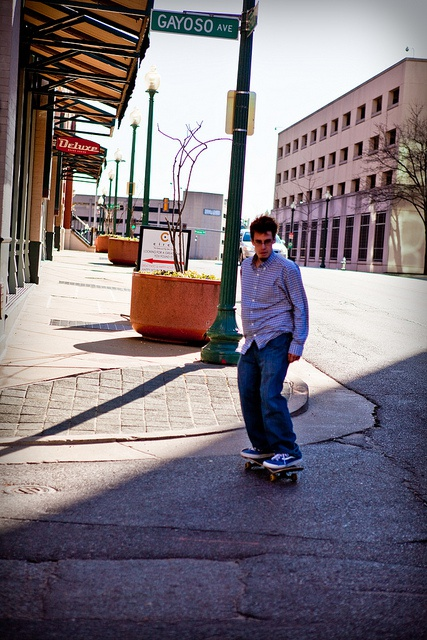Describe the objects in this image and their specific colors. I can see people in black, blue, navy, and purple tones, potted plant in black, brown, white, and maroon tones, potted plant in black, maroon, and khaki tones, skateboard in black, gray, and maroon tones, and traffic light in black, gray, red, and brown tones in this image. 